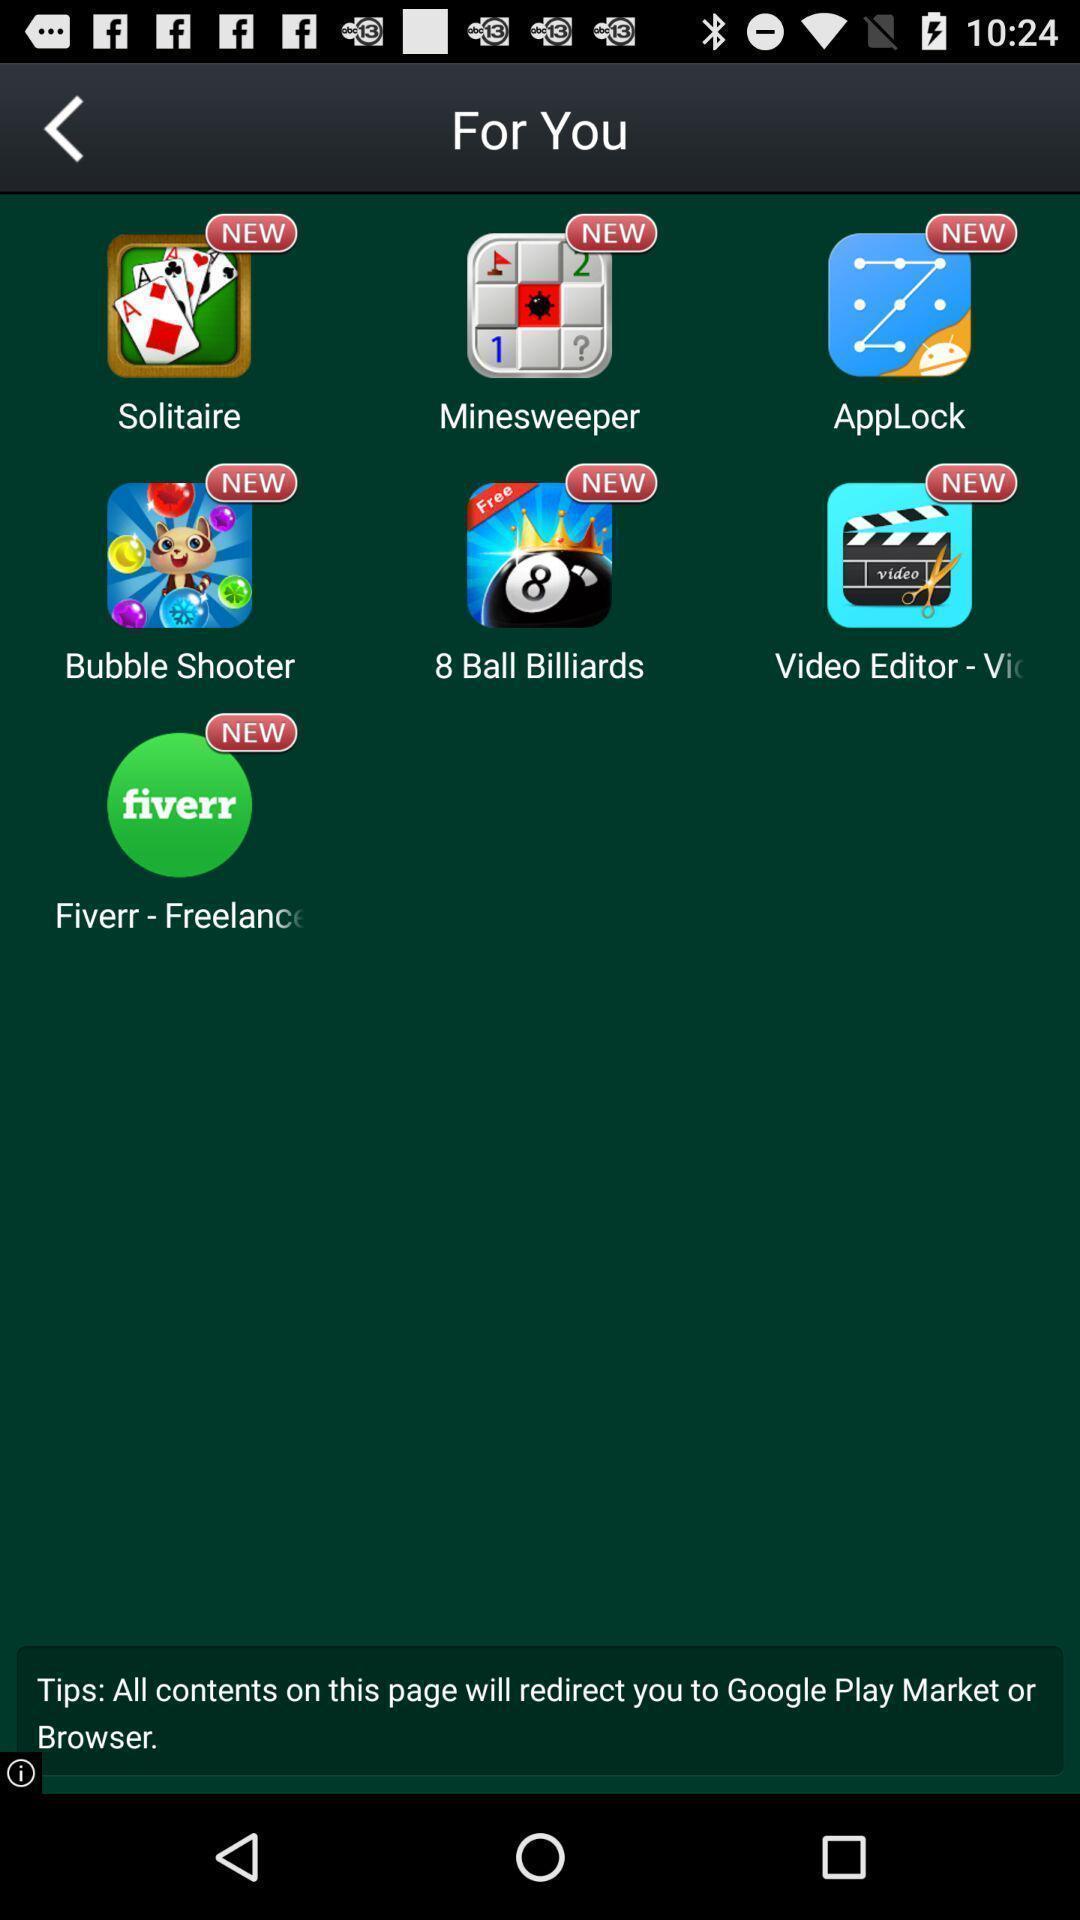Summarize the information in this screenshot. Screen displaying multiple application icons with names. 